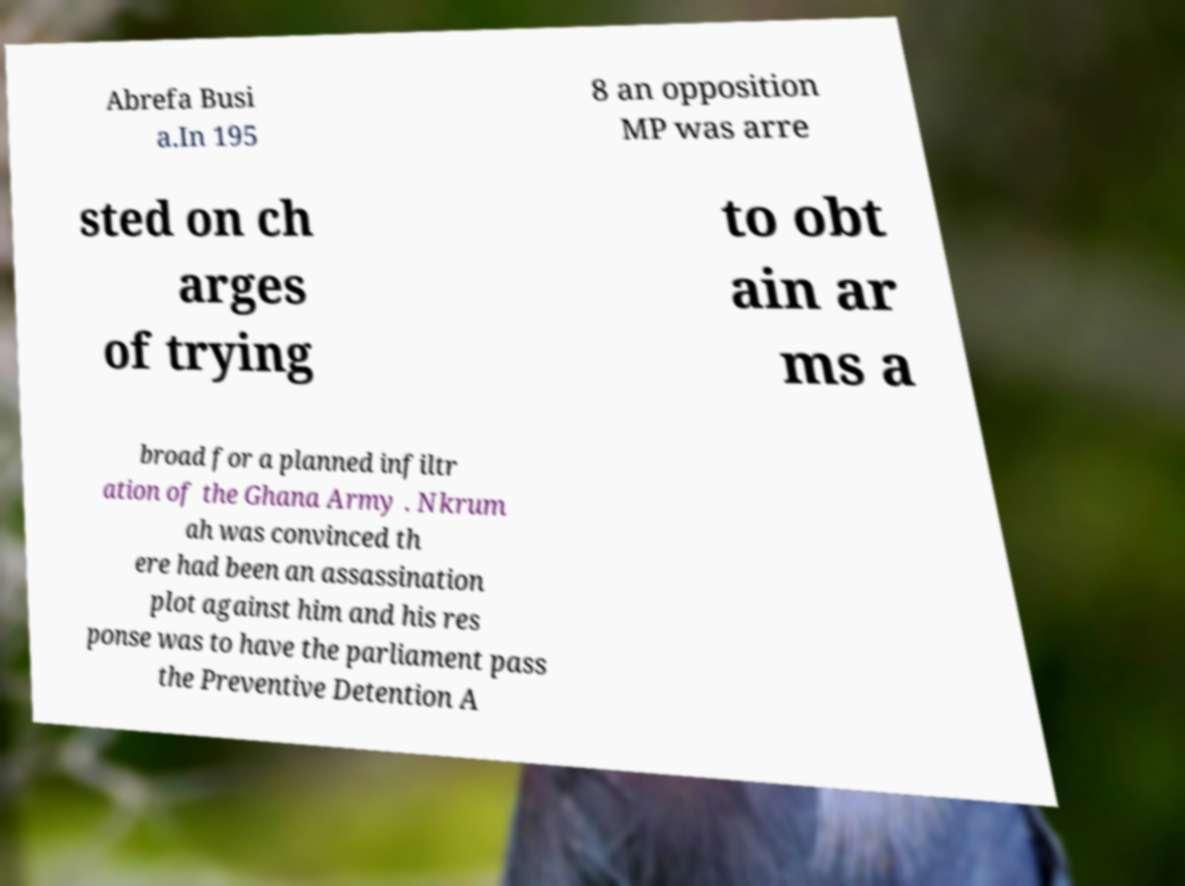Can you accurately transcribe the text from the provided image for me? Abrefa Busi a.In 195 8 an opposition MP was arre sted on ch arges of trying to obt ain ar ms a broad for a planned infiltr ation of the Ghana Army . Nkrum ah was convinced th ere had been an assassination plot against him and his res ponse was to have the parliament pass the Preventive Detention A 